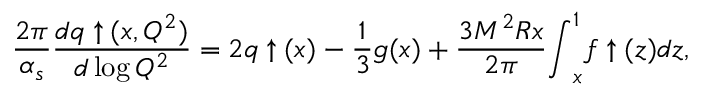Convert formula to latex. <formula><loc_0><loc_0><loc_500><loc_500>\frac { 2 \pi } { \alpha _ { s } } \frac { d q \uparrow ( x , Q ^ { 2 } ) } { d \log Q ^ { 2 } } = 2 q \uparrow ( x ) - \frac { 1 } { 3 } g ( x ) + \frac { 3 M ^ { 2 } R x } { 2 \pi } { \int } _ { x } ^ { 1 } f \uparrow ( z ) d z ,</formula> 